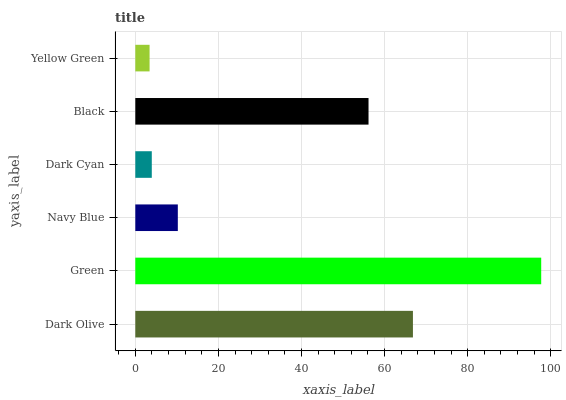Is Yellow Green the minimum?
Answer yes or no. Yes. Is Green the maximum?
Answer yes or no. Yes. Is Navy Blue the minimum?
Answer yes or no. No. Is Navy Blue the maximum?
Answer yes or no. No. Is Green greater than Navy Blue?
Answer yes or no. Yes. Is Navy Blue less than Green?
Answer yes or no. Yes. Is Navy Blue greater than Green?
Answer yes or no. No. Is Green less than Navy Blue?
Answer yes or no. No. Is Black the high median?
Answer yes or no. Yes. Is Navy Blue the low median?
Answer yes or no. Yes. Is Dark Olive the high median?
Answer yes or no. No. Is Yellow Green the low median?
Answer yes or no. No. 